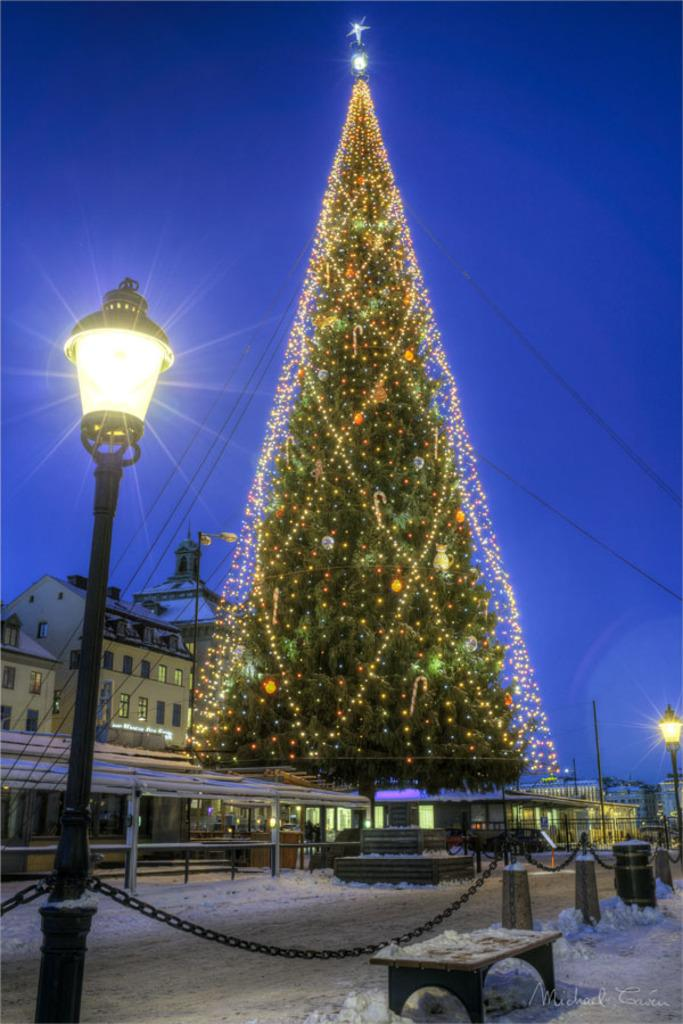What type of tree is decorated in the image? There is a Christmas tree with lights in the image. What kind of lighting is present in the image? There is a lantern lamp with a pole in the image. What can be seen in the background of the image? There are buildings with windows in the background of the image. What type of rock is being used as a representative for the carriage in the image? There is no rock or carriage present in the image. 